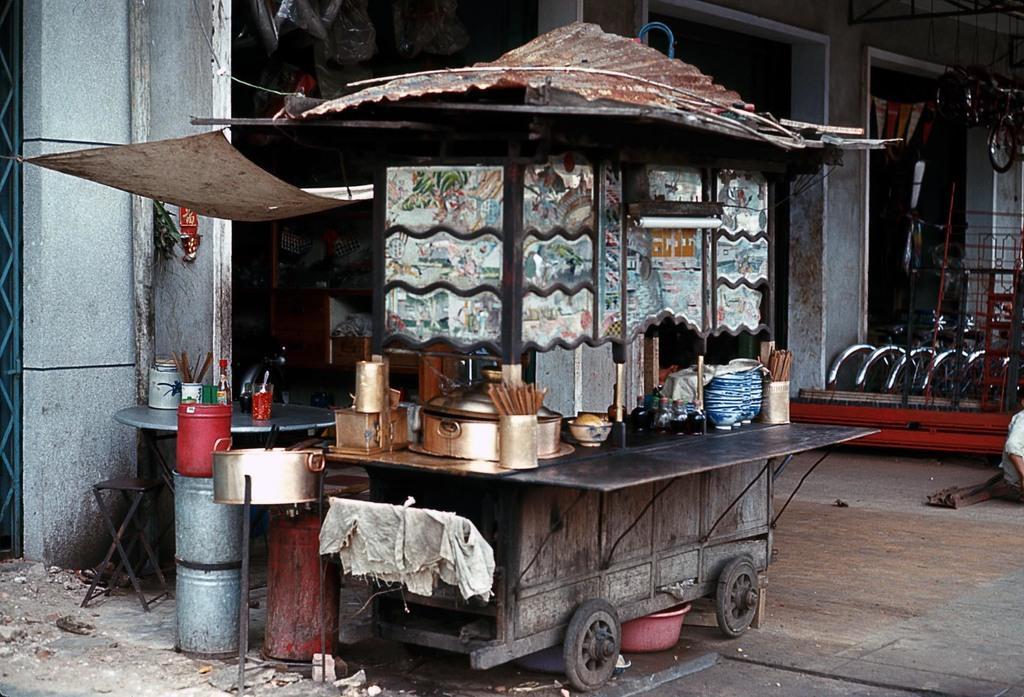Please provide a concise description of this image. In this image i can see a food court and at the background of the image there is a cycle shop. 